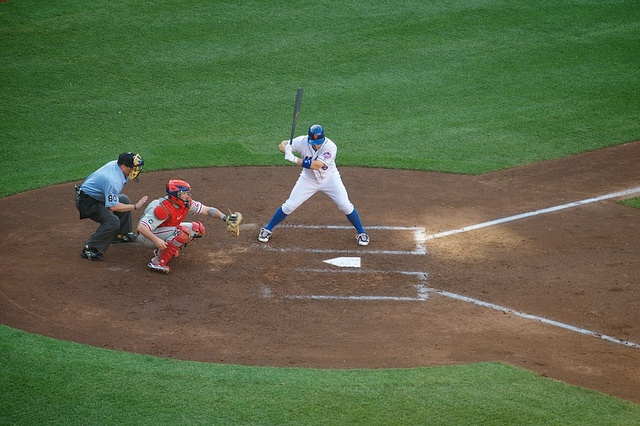Describe the objects in this image and their specific colors. I can see people in maroon, lavender, gray, and darkgray tones, people in maroon, black, gray, and lightblue tones, people in maroon, gray, brown, and darkgray tones, baseball glove in maroon, gray, tan, and darkgray tones, and baseball bat in maroon, teal, and darkgreen tones in this image. 